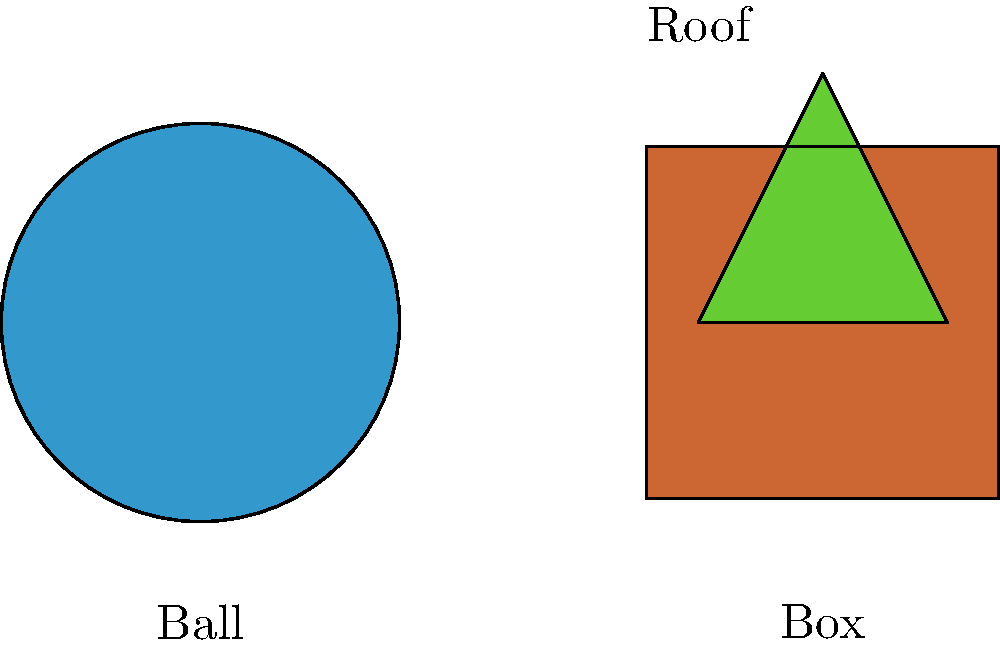Look at the picture of everyday objects. Can you match each object with its shape? Which shape is the ball? Let's look at each object and its shape:

1. Ball: The ball is round and has no corners or edges. It's perfectly circular from all angles. This shape is called a circle.

2. Box: The box has four equal sides and four corners. Each corner forms a right angle (90 degrees). This shape is called a square.

3. Roof: The roof has three sides and three corners. This shape is called a triangle.

In this question, we're asked specifically about the ball. The ball is clearly circular in shape, with no corners or edges.
Answer: Circle 